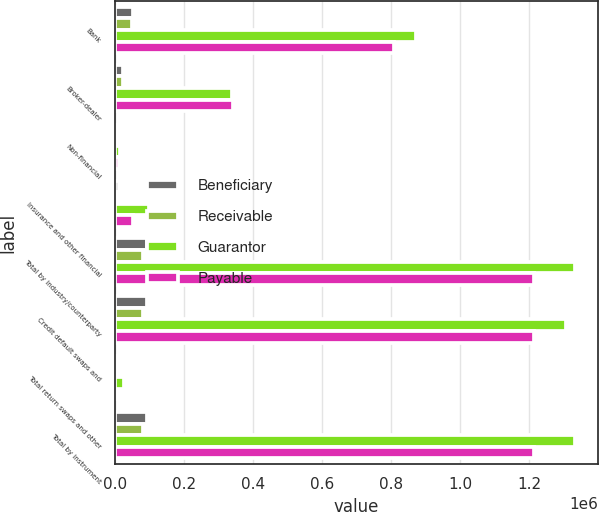Convert chart. <chart><loc_0><loc_0><loc_500><loc_500><stacked_bar_chart><ecel><fcel>Bank<fcel>Broker-dealer<fcel>Non-financial<fcel>Insurance and other financial<fcel>Total by industry/counterparty<fcel>Credit default swaps and<fcel>Total return swaps and other<fcel>Total by instrument<nl><fcel>Beneficiary<fcel>52383<fcel>23241<fcel>339<fcel>10969<fcel>92792<fcel>91625<fcel>1167<fcel>92792<nl><fcel>Receivable<fcel>50778<fcel>22932<fcel>371<fcel>8343<fcel>82424<fcel>81174<fcel>1250<fcel>82424<nl><fcel>Guarantor<fcel>872523<fcel>338829<fcel>13437<fcel>98155<fcel>1.33296e+06<fcel>1.30572e+06<fcel>27238<fcel>1.33296e+06<nl><fcel>Payable<fcel>807484<fcel>340949<fcel>13221<fcel>52366<fcel>1.21405e+06<fcel>1.21321e+06<fcel>845<fcel>1.21405e+06<nl></chart> 